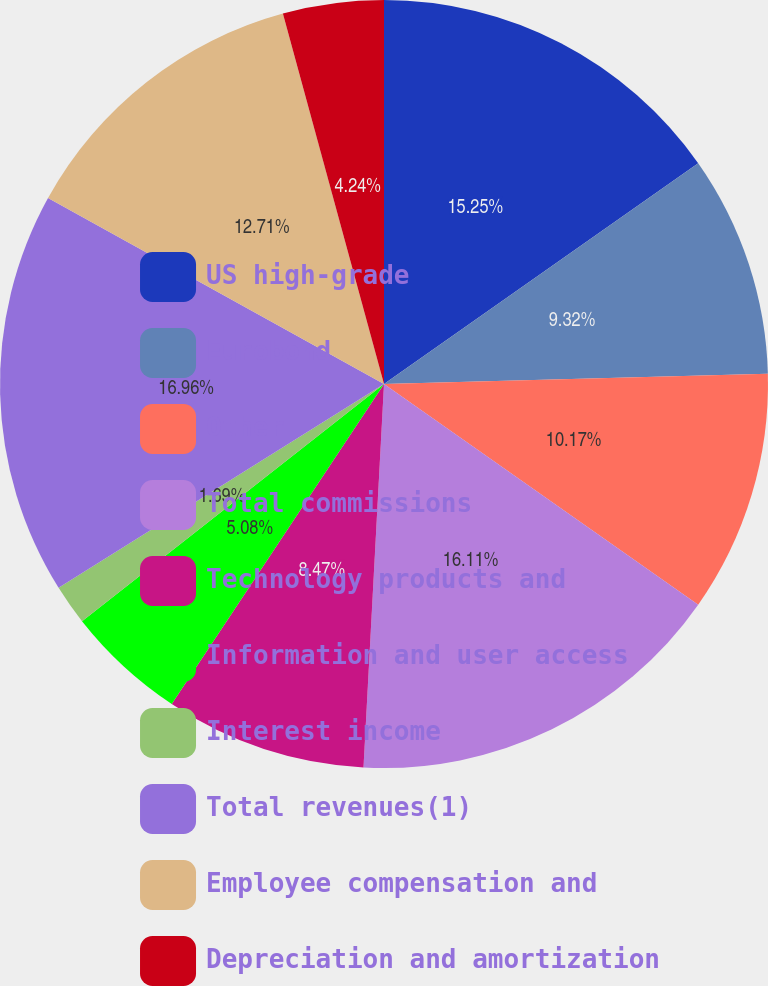Convert chart. <chart><loc_0><loc_0><loc_500><loc_500><pie_chart><fcel>US high-grade<fcel>Eurobond<fcel>Other<fcel>Total commissions<fcel>Technology products and<fcel>Information and user access<fcel>Interest income<fcel>Total revenues(1)<fcel>Employee compensation and<fcel>Depreciation and amortization<nl><fcel>15.25%<fcel>9.32%<fcel>10.17%<fcel>16.1%<fcel>8.47%<fcel>5.08%<fcel>1.69%<fcel>16.95%<fcel>12.71%<fcel>4.24%<nl></chart> 